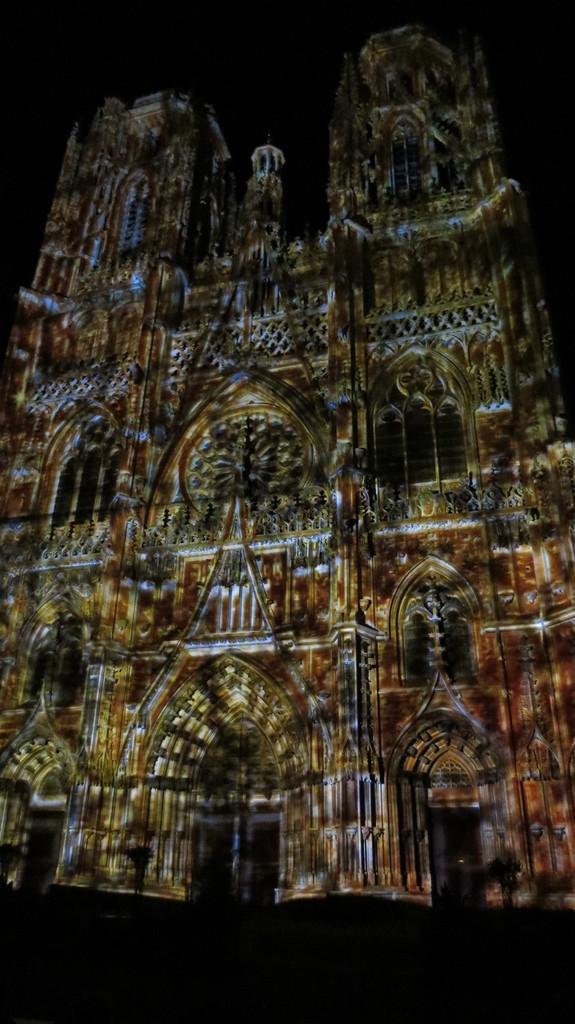Can you describe this image briefly? In the image we can see a building. 